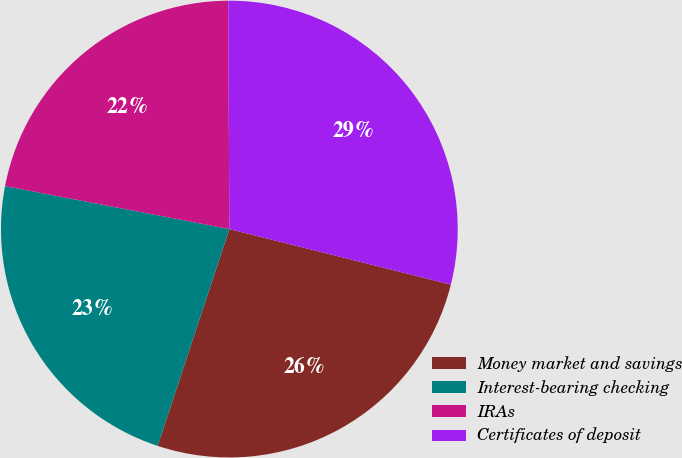Convert chart to OTSL. <chart><loc_0><loc_0><loc_500><loc_500><pie_chart><fcel>Money market and savings<fcel>Interest-bearing checking<fcel>IRAs<fcel>Certificates of deposit<nl><fcel>26.17%<fcel>22.93%<fcel>21.91%<fcel>28.99%<nl></chart> 